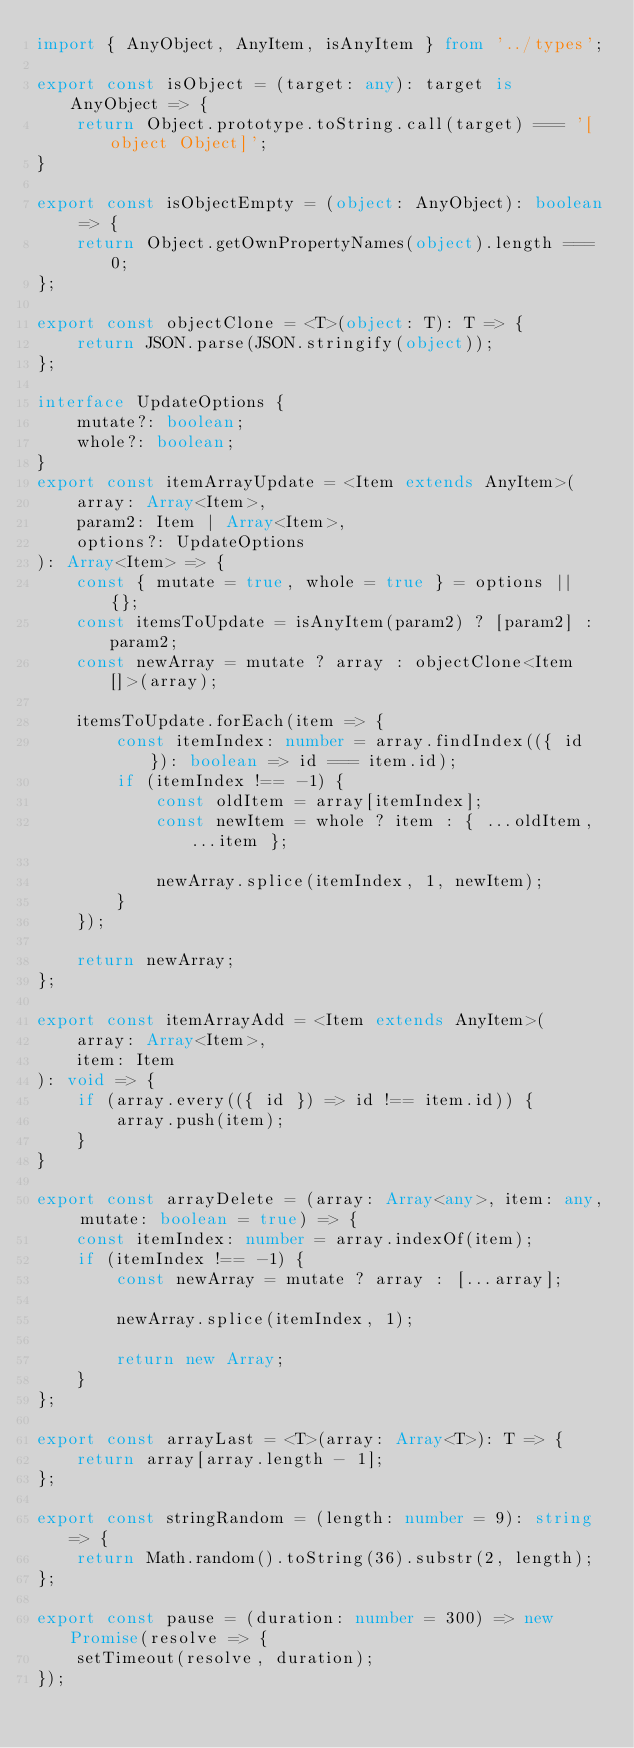Convert code to text. <code><loc_0><loc_0><loc_500><loc_500><_TypeScript_>import { AnyObject, AnyItem, isAnyItem } from '../types';

export const isObject = (target: any): target is AnyObject => {
    return Object.prototype.toString.call(target) === '[object Object]';
}

export const isObjectEmpty = (object: AnyObject): boolean => {
    return Object.getOwnPropertyNames(object).length === 0;
};

export const objectClone = <T>(object: T): T => {
    return JSON.parse(JSON.stringify(object));
};

interface UpdateOptions {
    mutate?: boolean;
    whole?: boolean;
}
export const itemArrayUpdate = <Item extends AnyItem>(
    array: Array<Item>,
    param2: Item | Array<Item>,
    options?: UpdateOptions
): Array<Item> => {
    const { mutate = true, whole = true } = options || {};
    const itemsToUpdate = isAnyItem(param2) ? [param2] : param2;
    const newArray = mutate ? array : objectClone<Item[]>(array);

    itemsToUpdate.forEach(item => {
        const itemIndex: number = array.findIndex(({ id }): boolean => id === item.id);
        if (itemIndex !== -1) {
            const oldItem = array[itemIndex];
            const newItem = whole ? item : { ...oldItem, ...item };
    
            newArray.splice(itemIndex, 1, newItem);
        }
    });

    return newArray;
};

export const itemArrayAdd = <Item extends AnyItem>(
    array: Array<Item>,
    item: Item
): void => {
    if (array.every(({ id }) => id !== item.id)) {
        array.push(item);
    }
}

export const arrayDelete = (array: Array<any>, item: any, mutate: boolean = true) => {
    const itemIndex: number = array.indexOf(item);
    if (itemIndex !== -1) {
        const newArray = mutate ? array : [...array];

        newArray.splice(itemIndex, 1);

        return new Array;
    }
};

export const arrayLast = <T>(array: Array<T>): T => {
    return array[array.length - 1];
};

export const stringRandom = (length: number = 9): string => {
    return Math.random().toString(36).substr(2, length);
};

export const pause = (duration: number = 300) => new Promise(resolve => {
    setTimeout(resolve, duration);
});
</code> 